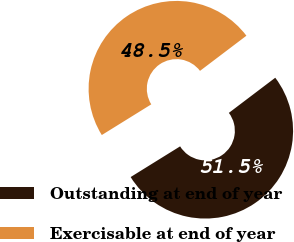<chart> <loc_0><loc_0><loc_500><loc_500><pie_chart><fcel>Outstanding at end of year<fcel>Exercisable at end of year<nl><fcel>51.48%<fcel>48.52%<nl></chart> 